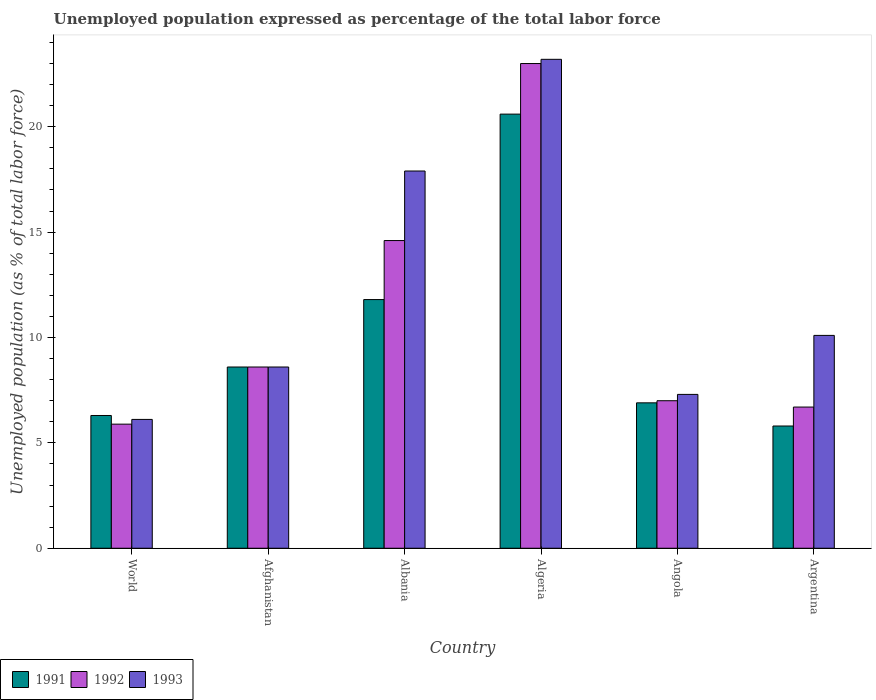How many different coloured bars are there?
Keep it short and to the point. 3. How many groups of bars are there?
Your response must be concise. 6. Are the number of bars on each tick of the X-axis equal?
Your answer should be very brief. Yes. How many bars are there on the 4th tick from the right?
Offer a terse response. 3. What is the label of the 4th group of bars from the left?
Provide a short and direct response. Algeria. What is the unemployment in in 1993 in Argentina?
Provide a succinct answer. 10.1. Across all countries, what is the maximum unemployment in in 1993?
Provide a succinct answer. 23.2. Across all countries, what is the minimum unemployment in in 1991?
Provide a succinct answer. 5.8. In which country was the unemployment in in 1991 maximum?
Provide a succinct answer. Algeria. In which country was the unemployment in in 1993 minimum?
Offer a terse response. World. What is the total unemployment in in 1993 in the graph?
Give a very brief answer. 73.21. What is the difference between the unemployment in in 1993 in Algeria and that in Argentina?
Offer a terse response. 13.1. What is the difference between the unemployment in in 1991 in Argentina and the unemployment in in 1992 in Angola?
Make the answer very short. -1.2. What is the average unemployment in in 1991 per country?
Offer a very short reply. 10. What is the difference between the unemployment in of/in 1993 and unemployment in of/in 1991 in Angola?
Give a very brief answer. 0.4. What is the ratio of the unemployment in in 1992 in Algeria to that in Angola?
Keep it short and to the point. 3.29. Is the difference between the unemployment in in 1993 in Algeria and Angola greater than the difference between the unemployment in in 1991 in Algeria and Angola?
Your answer should be compact. Yes. What is the difference between the highest and the second highest unemployment in in 1992?
Provide a succinct answer. -6. What is the difference between the highest and the lowest unemployment in in 1992?
Provide a short and direct response. 17.11. In how many countries, is the unemployment in in 1993 greater than the average unemployment in in 1993 taken over all countries?
Your response must be concise. 2. What does the 3rd bar from the left in Afghanistan represents?
Your response must be concise. 1993. What does the 1st bar from the right in Argentina represents?
Keep it short and to the point. 1993. What is the difference between two consecutive major ticks on the Y-axis?
Keep it short and to the point. 5. Are the values on the major ticks of Y-axis written in scientific E-notation?
Provide a succinct answer. No. Does the graph contain any zero values?
Your response must be concise. No. Where does the legend appear in the graph?
Make the answer very short. Bottom left. How many legend labels are there?
Make the answer very short. 3. What is the title of the graph?
Give a very brief answer. Unemployed population expressed as percentage of the total labor force. Does "2012" appear as one of the legend labels in the graph?
Your response must be concise. No. What is the label or title of the X-axis?
Ensure brevity in your answer.  Country. What is the label or title of the Y-axis?
Offer a very short reply. Unemployed population (as % of total labor force). What is the Unemployed population (as % of total labor force) in 1991 in World?
Make the answer very short. 6.3. What is the Unemployed population (as % of total labor force) in 1992 in World?
Offer a terse response. 5.89. What is the Unemployed population (as % of total labor force) in 1993 in World?
Make the answer very short. 6.11. What is the Unemployed population (as % of total labor force) of 1991 in Afghanistan?
Keep it short and to the point. 8.6. What is the Unemployed population (as % of total labor force) of 1992 in Afghanistan?
Your answer should be compact. 8.6. What is the Unemployed population (as % of total labor force) in 1993 in Afghanistan?
Offer a very short reply. 8.6. What is the Unemployed population (as % of total labor force) in 1991 in Albania?
Offer a very short reply. 11.8. What is the Unemployed population (as % of total labor force) in 1992 in Albania?
Give a very brief answer. 14.6. What is the Unemployed population (as % of total labor force) in 1993 in Albania?
Provide a succinct answer. 17.9. What is the Unemployed population (as % of total labor force) of 1991 in Algeria?
Make the answer very short. 20.6. What is the Unemployed population (as % of total labor force) of 1992 in Algeria?
Give a very brief answer. 23. What is the Unemployed population (as % of total labor force) in 1993 in Algeria?
Provide a succinct answer. 23.2. What is the Unemployed population (as % of total labor force) in 1991 in Angola?
Offer a terse response. 6.9. What is the Unemployed population (as % of total labor force) of 1993 in Angola?
Your response must be concise. 7.3. What is the Unemployed population (as % of total labor force) in 1991 in Argentina?
Provide a short and direct response. 5.8. What is the Unemployed population (as % of total labor force) in 1992 in Argentina?
Make the answer very short. 6.7. What is the Unemployed population (as % of total labor force) of 1993 in Argentina?
Offer a very short reply. 10.1. Across all countries, what is the maximum Unemployed population (as % of total labor force) in 1991?
Offer a terse response. 20.6. Across all countries, what is the maximum Unemployed population (as % of total labor force) of 1993?
Offer a very short reply. 23.2. Across all countries, what is the minimum Unemployed population (as % of total labor force) of 1991?
Offer a terse response. 5.8. Across all countries, what is the minimum Unemployed population (as % of total labor force) of 1992?
Offer a terse response. 5.89. Across all countries, what is the minimum Unemployed population (as % of total labor force) in 1993?
Your response must be concise. 6.11. What is the total Unemployed population (as % of total labor force) in 1991 in the graph?
Your answer should be compact. 60. What is the total Unemployed population (as % of total labor force) of 1992 in the graph?
Make the answer very short. 65.79. What is the total Unemployed population (as % of total labor force) of 1993 in the graph?
Offer a terse response. 73.21. What is the difference between the Unemployed population (as % of total labor force) of 1991 in World and that in Afghanistan?
Keep it short and to the point. -2.3. What is the difference between the Unemployed population (as % of total labor force) in 1992 in World and that in Afghanistan?
Make the answer very short. -2.71. What is the difference between the Unemployed population (as % of total labor force) in 1993 in World and that in Afghanistan?
Ensure brevity in your answer.  -2.49. What is the difference between the Unemployed population (as % of total labor force) of 1991 in World and that in Albania?
Provide a succinct answer. -5.5. What is the difference between the Unemployed population (as % of total labor force) in 1992 in World and that in Albania?
Provide a succinct answer. -8.71. What is the difference between the Unemployed population (as % of total labor force) in 1993 in World and that in Albania?
Your answer should be very brief. -11.79. What is the difference between the Unemployed population (as % of total labor force) in 1991 in World and that in Algeria?
Make the answer very short. -14.3. What is the difference between the Unemployed population (as % of total labor force) of 1992 in World and that in Algeria?
Offer a very short reply. -17.11. What is the difference between the Unemployed population (as % of total labor force) of 1993 in World and that in Algeria?
Give a very brief answer. -17.09. What is the difference between the Unemployed population (as % of total labor force) in 1991 in World and that in Angola?
Your answer should be very brief. -0.6. What is the difference between the Unemployed population (as % of total labor force) in 1992 in World and that in Angola?
Ensure brevity in your answer.  -1.11. What is the difference between the Unemployed population (as % of total labor force) in 1993 in World and that in Angola?
Provide a succinct answer. -1.19. What is the difference between the Unemployed population (as % of total labor force) of 1991 in World and that in Argentina?
Give a very brief answer. 0.5. What is the difference between the Unemployed population (as % of total labor force) in 1992 in World and that in Argentina?
Make the answer very short. -0.81. What is the difference between the Unemployed population (as % of total labor force) in 1993 in World and that in Argentina?
Offer a very short reply. -3.99. What is the difference between the Unemployed population (as % of total labor force) of 1991 in Afghanistan and that in Albania?
Ensure brevity in your answer.  -3.2. What is the difference between the Unemployed population (as % of total labor force) in 1991 in Afghanistan and that in Algeria?
Your answer should be very brief. -12. What is the difference between the Unemployed population (as % of total labor force) in 1992 in Afghanistan and that in Algeria?
Provide a short and direct response. -14.4. What is the difference between the Unemployed population (as % of total labor force) of 1993 in Afghanistan and that in Algeria?
Offer a terse response. -14.6. What is the difference between the Unemployed population (as % of total labor force) in 1992 in Afghanistan and that in Angola?
Provide a short and direct response. 1.6. What is the difference between the Unemployed population (as % of total labor force) of 1993 in Afghanistan and that in Angola?
Give a very brief answer. 1.3. What is the difference between the Unemployed population (as % of total labor force) of 1992 in Afghanistan and that in Argentina?
Give a very brief answer. 1.9. What is the difference between the Unemployed population (as % of total labor force) of 1993 in Albania and that in Algeria?
Provide a short and direct response. -5.3. What is the difference between the Unemployed population (as % of total labor force) in 1992 in Albania and that in Angola?
Provide a succinct answer. 7.6. What is the difference between the Unemployed population (as % of total labor force) of 1992 in Albania and that in Argentina?
Ensure brevity in your answer.  7.9. What is the difference between the Unemployed population (as % of total labor force) in 1993 in Albania and that in Argentina?
Provide a succinct answer. 7.8. What is the difference between the Unemployed population (as % of total labor force) in 1991 in Algeria and that in Angola?
Provide a succinct answer. 13.7. What is the difference between the Unemployed population (as % of total labor force) of 1993 in Algeria and that in Angola?
Offer a terse response. 15.9. What is the difference between the Unemployed population (as % of total labor force) of 1993 in Angola and that in Argentina?
Offer a terse response. -2.8. What is the difference between the Unemployed population (as % of total labor force) in 1991 in World and the Unemployed population (as % of total labor force) in 1992 in Afghanistan?
Ensure brevity in your answer.  -2.3. What is the difference between the Unemployed population (as % of total labor force) in 1991 in World and the Unemployed population (as % of total labor force) in 1993 in Afghanistan?
Provide a succinct answer. -2.3. What is the difference between the Unemployed population (as % of total labor force) in 1992 in World and the Unemployed population (as % of total labor force) in 1993 in Afghanistan?
Keep it short and to the point. -2.71. What is the difference between the Unemployed population (as % of total labor force) in 1991 in World and the Unemployed population (as % of total labor force) in 1992 in Albania?
Keep it short and to the point. -8.3. What is the difference between the Unemployed population (as % of total labor force) of 1991 in World and the Unemployed population (as % of total labor force) of 1993 in Albania?
Your answer should be very brief. -11.6. What is the difference between the Unemployed population (as % of total labor force) of 1992 in World and the Unemployed population (as % of total labor force) of 1993 in Albania?
Offer a very short reply. -12.01. What is the difference between the Unemployed population (as % of total labor force) in 1991 in World and the Unemployed population (as % of total labor force) in 1992 in Algeria?
Provide a succinct answer. -16.7. What is the difference between the Unemployed population (as % of total labor force) in 1991 in World and the Unemployed population (as % of total labor force) in 1993 in Algeria?
Your answer should be very brief. -16.9. What is the difference between the Unemployed population (as % of total labor force) in 1992 in World and the Unemployed population (as % of total labor force) in 1993 in Algeria?
Your response must be concise. -17.31. What is the difference between the Unemployed population (as % of total labor force) of 1991 in World and the Unemployed population (as % of total labor force) of 1992 in Angola?
Offer a very short reply. -0.7. What is the difference between the Unemployed population (as % of total labor force) of 1991 in World and the Unemployed population (as % of total labor force) of 1993 in Angola?
Your response must be concise. -1. What is the difference between the Unemployed population (as % of total labor force) of 1992 in World and the Unemployed population (as % of total labor force) of 1993 in Angola?
Your response must be concise. -1.41. What is the difference between the Unemployed population (as % of total labor force) of 1991 in World and the Unemployed population (as % of total labor force) of 1992 in Argentina?
Keep it short and to the point. -0.4. What is the difference between the Unemployed population (as % of total labor force) of 1991 in World and the Unemployed population (as % of total labor force) of 1993 in Argentina?
Offer a terse response. -3.8. What is the difference between the Unemployed population (as % of total labor force) of 1992 in World and the Unemployed population (as % of total labor force) of 1993 in Argentina?
Ensure brevity in your answer.  -4.21. What is the difference between the Unemployed population (as % of total labor force) of 1991 in Afghanistan and the Unemployed population (as % of total labor force) of 1993 in Albania?
Keep it short and to the point. -9.3. What is the difference between the Unemployed population (as % of total labor force) of 1992 in Afghanistan and the Unemployed population (as % of total labor force) of 1993 in Albania?
Your answer should be very brief. -9.3. What is the difference between the Unemployed population (as % of total labor force) of 1991 in Afghanistan and the Unemployed population (as % of total labor force) of 1992 in Algeria?
Make the answer very short. -14.4. What is the difference between the Unemployed population (as % of total labor force) in 1991 in Afghanistan and the Unemployed population (as % of total labor force) in 1993 in Algeria?
Give a very brief answer. -14.6. What is the difference between the Unemployed population (as % of total labor force) in 1992 in Afghanistan and the Unemployed population (as % of total labor force) in 1993 in Algeria?
Give a very brief answer. -14.6. What is the difference between the Unemployed population (as % of total labor force) of 1992 in Afghanistan and the Unemployed population (as % of total labor force) of 1993 in Angola?
Your response must be concise. 1.3. What is the difference between the Unemployed population (as % of total labor force) in 1991 in Albania and the Unemployed population (as % of total labor force) in 1993 in Algeria?
Offer a very short reply. -11.4. What is the difference between the Unemployed population (as % of total labor force) in 1992 in Albania and the Unemployed population (as % of total labor force) in 1993 in Algeria?
Provide a succinct answer. -8.6. What is the difference between the Unemployed population (as % of total labor force) of 1991 in Albania and the Unemployed population (as % of total labor force) of 1992 in Angola?
Provide a succinct answer. 4.8. What is the difference between the Unemployed population (as % of total labor force) of 1991 in Albania and the Unemployed population (as % of total labor force) of 1993 in Angola?
Ensure brevity in your answer.  4.5. What is the difference between the Unemployed population (as % of total labor force) in 1992 in Albania and the Unemployed population (as % of total labor force) in 1993 in Angola?
Your answer should be compact. 7.3. What is the difference between the Unemployed population (as % of total labor force) of 1991 in Albania and the Unemployed population (as % of total labor force) of 1992 in Argentina?
Give a very brief answer. 5.1. What is the difference between the Unemployed population (as % of total labor force) of 1991 in Albania and the Unemployed population (as % of total labor force) of 1993 in Argentina?
Your answer should be very brief. 1.7. What is the difference between the Unemployed population (as % of total labor force) of 1991 in Algeria and the Unemployed population (as % of total labor force) of 1992 in Angola?
Provide a short and direct response. 13.6. What is the difference between the Unemployed population (as % of total labor force) of 1992 in Algeria and the Unemployed population (as % of total labor force) of 1993 in Angola?
Ensure brevity in your answer.  15.7. What is the difference between the Unemployed population (as % of total labor force) in 1991 in Algeria and the Unemployed population (as % of total labor force) in 1992 in Argentina?
Offer a terse response. 13.9. What is the difference between the Unemployed population (as % of total labor force) in 1992 in Algeria and the Unemployed population (as % of total labor force) in 1993 in Argentina?
Offer a very short reply. 12.9. What is the difference between the Unemployed population (as % of total labor force) in 1991 in Angola and the Unemployed population (as % of total labor force) in 1992 in Argentina?
Ensure brevity in your answer.  0.2. What is the average Unemployed population (as % of total labor force) of 1991 per country?
Provide a short and direct response. 10. What is the average Unemployed population (as % of total labor force) of 1992 per country?
Make the answer very short. 10.96. What is the average Unemployed population (as % of total labor force) of 1993 per country?
Keep it short and to the point. 12.2. What is the difference between the Unemployed population (as % of total labor force) in 1991 and Unemployed population (as % of total labor force) in 1992 in World?
Your response must be concise. 0.41. What is the difference between the Unemployed population (as % of total labor force) of 1991 and Unemployed population (as % of total labor force) of 1993 in World?
Give a very brief answer. 0.19. What is the difference between the Unemployed population (as % of total labor force) in 1992 and Unemployed population (as % of total labor force) in 1993 in World?
Your answer should be very brief. -0.23. What is the difference between the Unemployed population (as % of total labor force) of 1991 and Unemployed population (as % of total labor force) of 1993 in Afghanistan?
Provide a short and direct response. 0. What is the difference between the Unemployed population (as % of total labor force) in 1991 and Unemployed population (as % of total labor force) in 1992 in Albania?
Your answer should be very brief. -2.8. What is the difference between the Unemployed population (as % of total labor force) of 1991 and Unemployed population (as % of total labor force) of 1992 in Algeria?
Ensure brevity in your answer.  -2.4. What is the difference between the Unemployed population (as % of total labor force) of 1991 and Unemployed population (as % of total labor force) of 1993 in Algeria?
Offer a very short reply. -2.6. What is the difference between the Unemployed population (as % of total labor force) of 1992 and Unemployed population (as % of total labor force) of 1993 in Algeria?
Provide a short and direct response. -0.2. What is the difference between the Unemployed population (as % of total labor force) in 1991 and Unemployed population (as % of total labor force) in 1992 in Argentina?
Make the answer very short. -0.9. What is the difference between the Unemployed population (as % of total labor force) in 1991 and Unemployed population (as % of total labor force) in 1993 in Argentina?
Ensure brevity in your answer.  -4.3. What is the difference between the Unemployed population (as % of total labor force) of 1992 and Unemployed population (as % of total labor force) of 1993 in Argentina?
Ensure brevity in your answer.  -3.4. What is the ratio of the Unemployed population (as % of total labor force) of 1991 in World to that in Afghanistan?
Offer a terse response. 0.73. What is the ratio of the Unemployed population (as % of total labor force) in 1992 in World to that in Afghanistan?
Your answer should be very brief. 0.68. What is the ratio of the Unemployed population (as % of total labor force) of 1993 in World to that in Afghanistan?
Ensure brevity in your answer.  0.71. What is the ratio of the Unemployed population (as % of total labor force) in 1991 in World to that in Albania?
Ensure brevity in your answer.  0.53. What is the ratio of the Unemployed population (as % of total labor force) of 1992 in World to that in Albania?
Offer a very short reply. 0.4. What is the ratio of the Unemployed population (as % of total labor force) in 1993 in World to that in Albania?
Give a very brief answer. 0.34. What is the ratio of the Unemployed population (as % of total labor force) in 1991 in World to that in Algeria?
Ensure brevity in your answer.  0.31. What is the ratio of the Unemployed population (as % of total labor force) in 1992 in World to that in Algeria?
Offer a terse response. 0.26. What is the ratio of the Unemployed population (as % of total labor force) in 1993 in World to that in Algeria?
Provide a short and direct response. 0.26. What is the ratio of the Unemployed population (as % of total labor force) in 1991 in World to that in Angola?
Offer a terse response. 0.91. What is the ratio of the Unemployed population (as % of total labor force) in 1992 in World to that in Angola?
Offer a terse response. 0.84. What is the ratio of the Unemployed population (as % of total labor force) in 1993 in World to that in Angola?
Offer a terse response. 0.84. What is the ratio of the Unemployed population (as % of total labor force) in 1991 in World to that in Argentina?
Your response must be concise. 1.09. What is the ratio of the Unemployed population (as % of total labor force) of 1992 in World to that in Argentina?
Your response must be concise. 0.88. What is the ratio of the Unemployed population (as % of total labor force) of 1993 in World to that in Argentina?
Provide a succinct answer. 0.61. What is the ratio of the Unemployed population (as % of total labor force) of 1991 in Afghanistan to that in Albania?
Offer a terse response. 0.73. What is the ratio of the Unemployed population (as % of total labor force) of 1992 in Afghanistan to that in Albania?
Make the answer very short. 0.59. What is the ratio of the Unemployed population (as % of total labor force) of 1993 in Afghanistan to that in Albania?
Ensure brevity in your answer.  0.48. What is the ratio of the Unemployed population (as % of total labor force) of 1991 in Afghanistan to that in Algeria?
Ensure brevity in your answer.  0.42. What is the ratio of the Unemployed population (as % of total labor force) in 1992 in Afghanistan to that in Algeria?
Provide a succinct answer. 0.37. What is the ratio of the Unemployed population (as % of total labor force) in 1993 in Afghanistan to that in Algeria?
Your response must be concise. 0.37. What is the ratio of the Unemployed population (as % of total labor force) of 1991 in Afghanistan to that in Angola?
Your answer should be very brief. 1.25. What is the ratio of the Unemployed population (as % of total labor force) in 1992 in Afghanistan to that in Angola?
Offer a terse response. 1.23. What is the ratio of the Unemployed population (as % of total labor force) of 1993 in Afghanistan to that in Angola?
Offer a terse response. 1.18. What is the ratio of the Unemployed population (as % of total labor force) in 1991 in Afghanistan to that in Argentina?
Your answer should be very brief. 1.48. What is the ratio of the Unemployed population (as % of total labor force) of 1992 in Afghanistan to that in Argentina?
Offer a terse response. 1.28. What is the ratio of the Unemployed population (as % of total labor force) in 1993 in Afghanistan to that in Argentina?
Give a very brief answer. 0.85. What is the ratio of the Unemployed population (as % of total labor force) of 1991 in Albania to that in Algeria?
Your answer should be very brief. 0.57. What is the ratio of the Unemployed population (as % of total labor force) in 1992 in Albania to that in Algeria?
Keep it short and to the point. 0.63. What is the ratio of the Unemployed population (as % of total labor force) of 1993 in Albania to that in Algeria?
Offer a very short reply. 0.77. What is the ratio of the Unemployed population (as % of total labor force) in 1991 in Albania to that in Angola?
Keep it short and to the point. 1.71. What is the ratio of the Unemployed population (as % of total labor force) of 1992 in Albania to that in Angola?
Keep it short and to the point. 2.09. What is the ratio of the Unemployed population (as % of total labor force) in 1993 in Albania to that in Angola?
Provide a short and direct response. 2.45. What is the ratio of the Unemployed population (as % of total labor force) in 1991 in Albania to that in Argentina?
Give a very brief answer. 2.03. What is the ratio of the Unemployed population (as % of total labor force) of 1992 in Albania to that in Argentina?
Your answer should be very brief. 2.18. What is the ratio of the Unemployed population (as % of total labor force) in 1993 in Albania to that in Argentina?
Offer a very short reply. 1.77. What is the ratio of the Unemployed population (as % of total labor force) of 1991 in Algeria to that in Angola?
Provide a succinct answer. 2.99. What is the ratio of the Unemployed population (as % of total labor force) of 1992 in Algeria to that in Angola?
Your answer should be very brief. 3.29. What is the ratio of the Unemployed population (as % of total labor force) in 1993 in Algeria to that in Angola?
Provide a short and direct response. 3.18. What is the ratio of the Unemployed population (as % of total labor force) of 1991 in Algeria to that in Argentina?
Your answer should be very brief. 3.55. What is the ratio of the Unemployed population (as % of total labor force) in 1992 in Algeria to that in Argentina?
Your response must be concise. 3.43. What is the ratio of the Unemployed population (as % of total labor force) of 1993 in Algeria to that in Argentina?
Keep it short and to the point. 2.3. What is the ratio of the Unemployed population (as % of total labor force) in 1991 in Angola to that in Argentina?
Offer a very short reply. 1.19. What is the ratio of the Unemployed population (as % of total labor force) in 1992 in Angola to that in Argentina?
Your answer should be very brief. 1.04. What is the ratio of the Unemployed population (as % of total labor force) in 1993 in Angola to that in Argentina?
Offer a very short reply. 0.72. What is the difference between the highest and the second highest Unemployed population (as % of total labor force) in 1991?
Your answer should be very brief. 8.8. What is the difference between the highest and the lowest Unemployed population (as % of total labor force) in 1991?
Give a very brief answer. 14.8. What is the difference between the highest and the lowest Unemployed population (as % of total labor force) in 1992?
Your answer should be very brief. 17.11. What is the difference between the highest and the lowest Unemployed population (as % of total labor force) of 1993?
Your answer should be compact. 17.09. 